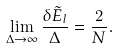<formula> <loc_0><loc_0><loc_500><loc_500>\lim _ { \Delta \rightarrow \infty } \frac { \delta \tilde { E } _ { l } } { \Delta } = \frac { 2 } { N } .</formula> 